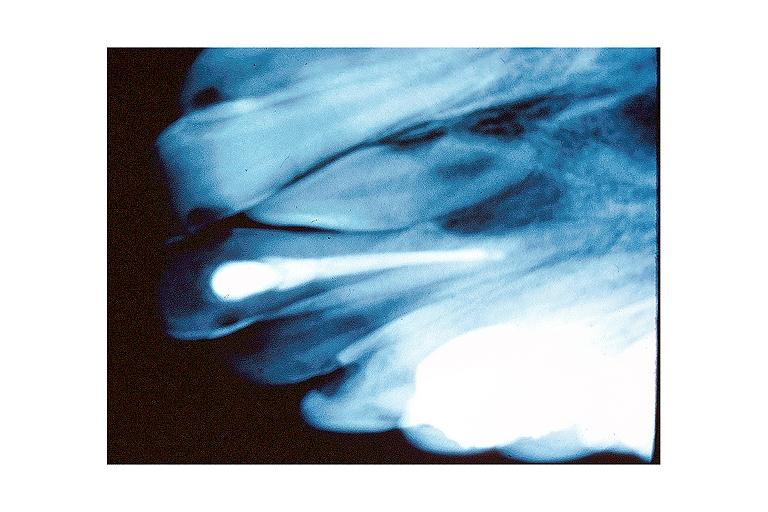s oral present?
Answer the question using a single word or phrase. Yes 